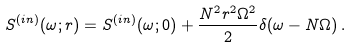Convert formula to latex. <formula><loc_0><loc_0><loc_500><loc_500>S ^ { ( i n ) } ( \omega ; r ) = S ^ { ( i n ) } ( \omega ; 0 ) + \frac { N ^ { 2 } r ^ { 2 } \Omega ^ { 2 } } { 2 } \delta ( \omega - N \Omega ) \, .</formula> 